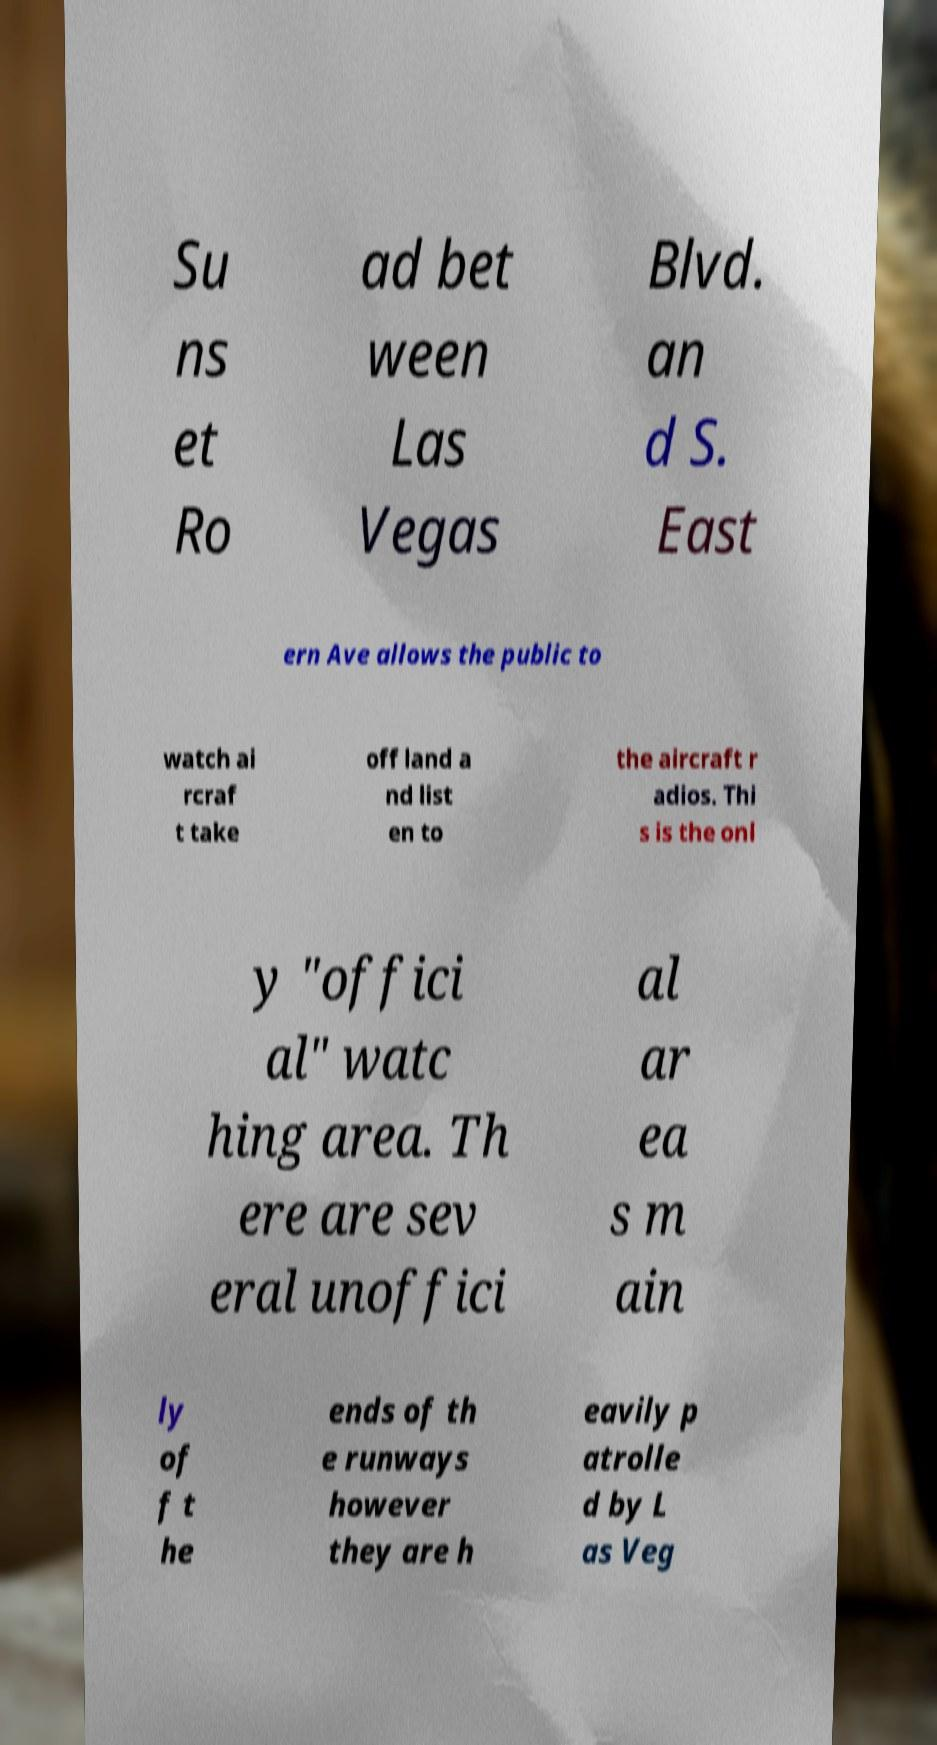Could you extract and type out the text from this image? Su ns et Ro ad bet ween Las Vegas Blvd. an d S. East ern Ave allows the public to watch ai rcraf t take off land a nd list en to the aircraft r adios. Thi s is the onl y "offici al" watc hing area. Th ere are sev eral unoffici al ar ea s m ain ly of f t he ends of th e runways however they are h eavily p atrolle d by L as Veg 